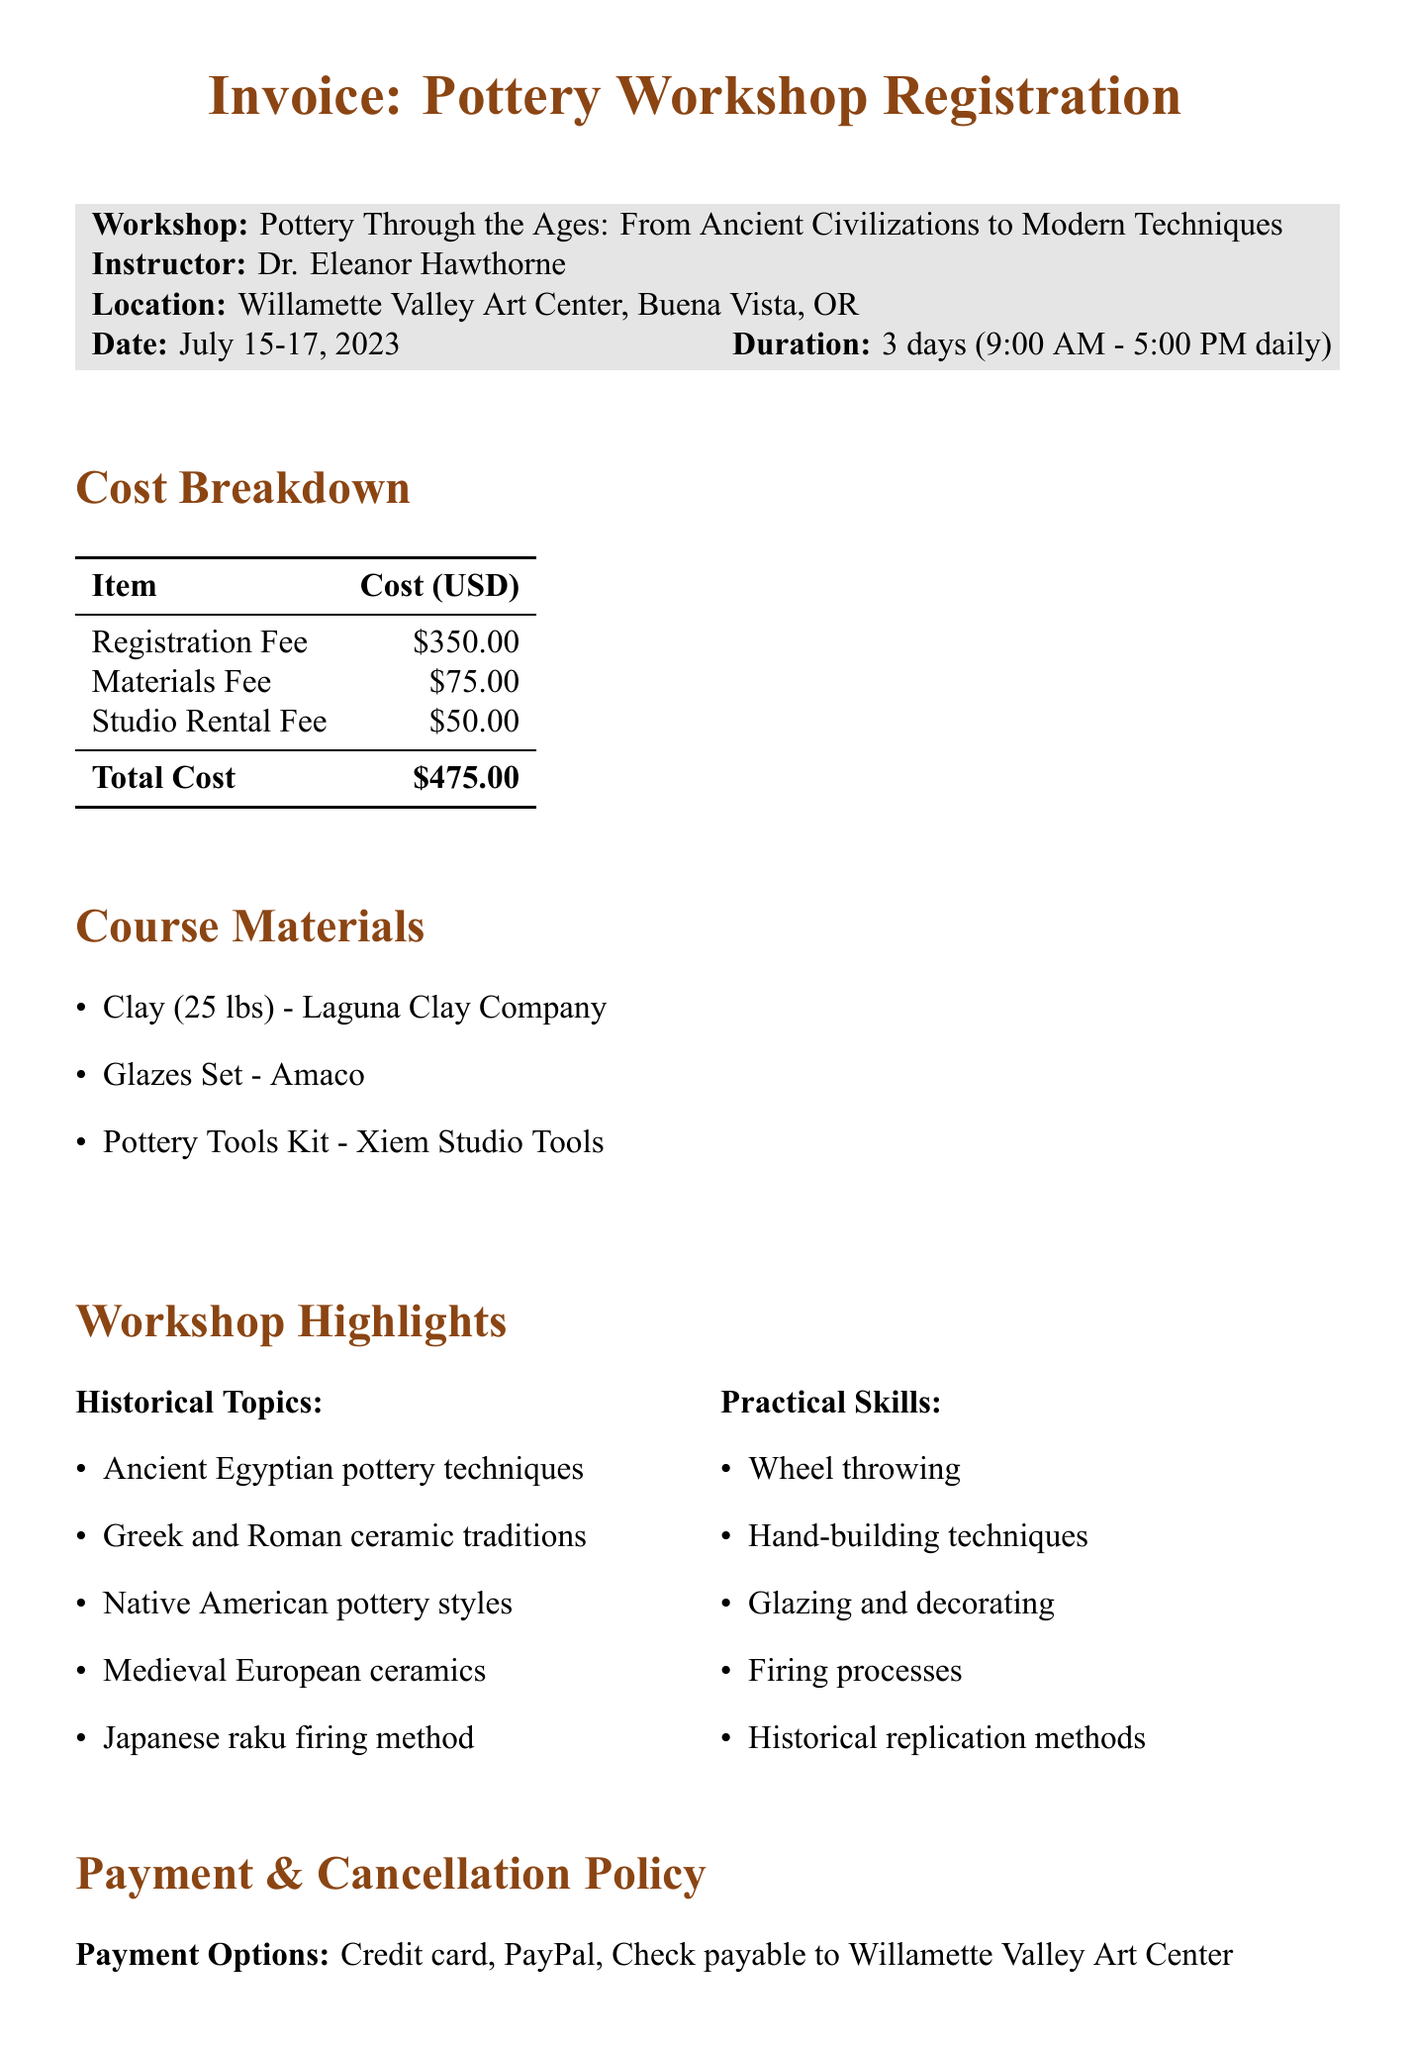What is the title of the workshop? The title is found at the beginning of the document, indicating the main focus of the event.
Answer: Pottery Through the Ages: From Ancient Civilizations to Modern Techniques Who is the instructor for the workshop? The instructor's name is listed next to the title of the workshop for easy identification.
Answer: Dr. Eleanor Hawthorne What is the total cost of the workshop? The total cost is provided in the cost breakdown section, summarizing all fees.
Answer: $475.00 How many days does the workshop last? The duration is mentioned alongside the date, giving participants an idea of the schedule.
Answer: 3 days What is the materials fee for the workshop? The materials fee is shown in the cost breakdown, indicating the additional charge for supplies.
Answer: $75.00 What payment options are available? The document outlines the accepted methods for payment, specifying the flexibility for participants.
Answer: Credit card, PayPal, Check payable to Willamette Valley Art Center What is included in the studio amenities? The studio amenities section lists equipment available during the workshop for practical exercises.
Answer: 10 Brent CXC pottery wheels What is the cancellation policy? The cancellation policy is detailed to inform participants of the terms regarding refunds.
Answer: Full refund if cancelled 14 days before the workshop Which pottery technique is included in the practical skills? The practical skills section identifies specific techniques that participants will learn or practice.
Answer: Wheel throwing 